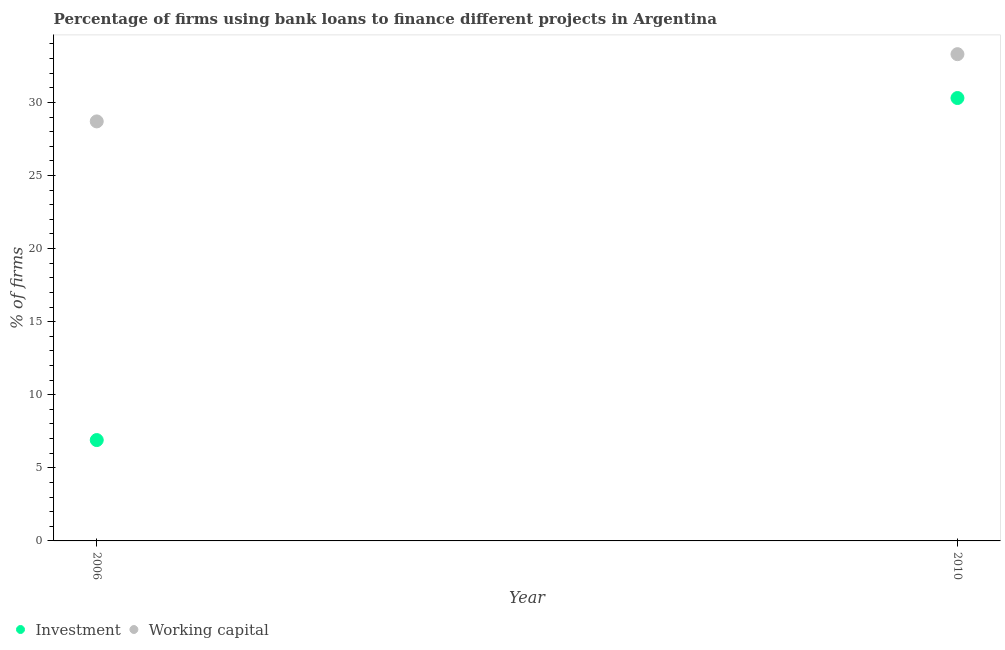How many different coloured dotlines are there?
Keep it short and to the point. 2. What is the percentage of firms using banks to finance investment in 2010?
Keep it short and to the point. 30.3. Across all years, what is the maximum percentage of firms using banks to finance investment?
Keep it short and to the point. 30.3. In which year was the percentage of firms using banks to finance working capital maximum?
Offer a very short reply. 2010. What is the total percentage of firms using banks to finance investment in the graph?
Provide a succinct answer. 37.2. What is the difference between the percentage of firms using banks to finance investment in 2006 and that in 2010?
Your answer should be very brief. -23.4. What is the difference between the percentage of firms using banks to finance working capital in 2010 and the percentage of firms using banks to finance investment in 2006?
Ensure brevity in your answer.  26.4. What is the average percentage of firms using banks to finance investment per year?
Keep it short and to the point. 18.6. In the year 2010, what is the difference between the percentage of firms using banks to finance working capital and percentage of firms using banks to finance investment?
Make the answer very short. 3. What is the ratio of the percentage of firms using banks to finance investment in 2006 to that in 2010?
Make the answer very short. 0.23. Is the percentage of firms using banks to finance investment in 2006 less than that in 2010?
Offer a terse response. Yes. Is the percentage of firms using banks to finance investment strictly less than the percentage of firms using banks to finance working capital over the years?
Your answer should be compact. Yes. Are the values on the major ticks of Y-axis written in scientific E-notation?
Provide a succinct answer. No. Where does the legend appear in the graph?
Offer a terse response. Bottom left. How many legend labels are there?
Your response must be concise. 2. How are the legend labels stacked?
Ensure brevity in your answer.  Horizontal. What is the title of the graph?
Offer a terse response. Percentage of firms using bank loans to finance different projects in Argentina. What is the label or title of the Y-axis?
Provide a succinct answer. % of firms. What is the % of firms of Working capital in 2006?
Provide a short and direct response. 28.7. What is the % of firms of Investment in 2010?
Offer a very short reply. 30.3. What is the % of firms in Working capital in 2010?
Offer a very short reply. 33.3. Across all years, what is the maximum % of firms in Investment?
Your answer should be very brief. 30.3. Across all years, what is the maximum % of firms of Working capital?
Keep it short and to the point. 33.3. Across all years, what is the minimum % of firms in Investment?
Provide a succinct answer. 6.9. Across all years, what is the minimum % of firms of Working capital?
Make the answer very short. 28.7. What is the total % of firms in Investment in the graph?
Provide a succinct answer. 37.2. What is the total % of firms of Working capital in the graph?
Offer a terse response. 62. What is the difference between the % of firms of Investment in 2006 and that in 2010?
Offer a very short reply. -23.4. What is the difference between the % of firms of Working capital in 2006 and that in 2010?
Give a very brief answer. -4.6. What is the difference between the % of firms of Investment in 2006 and the % of firms of Working capital in 2010?
Give a very brief answer. -26.4. What is the average % of firms in Investment per year?
Ensure brevity in your answer.  18.6. What is the average % of firms of Working capital per year?
Ensure brevity in your answer.  31. In the year 2006, what is the difference between the % of firms of Investment and % of firms of Working capital?
Make the answer very short. -21.8. In the year 2010, what is the difference between the % of firms in Investment and % of firms in Working capital?
Ensure brevity in your answer.  -3. What is the ratio of the % of firms in Investment in 2006 to that in 2010?
Keep it short and to the point. 0.23. What is the ratio of the % of firms in Working capital in 2006 to that in 2010?
Provide a succinct answer. 0.86. What is the difference between the highest and the second highest % of firms of Investment?
Give a very brief answer. 23.4. What is the difference between the highest and the second highest % of firms in Working capital?
Your response must be concise. 4.6. What is the difference between the highest and the lowest % of firms in Investment?
Provide a short and direct response. 23.4. 